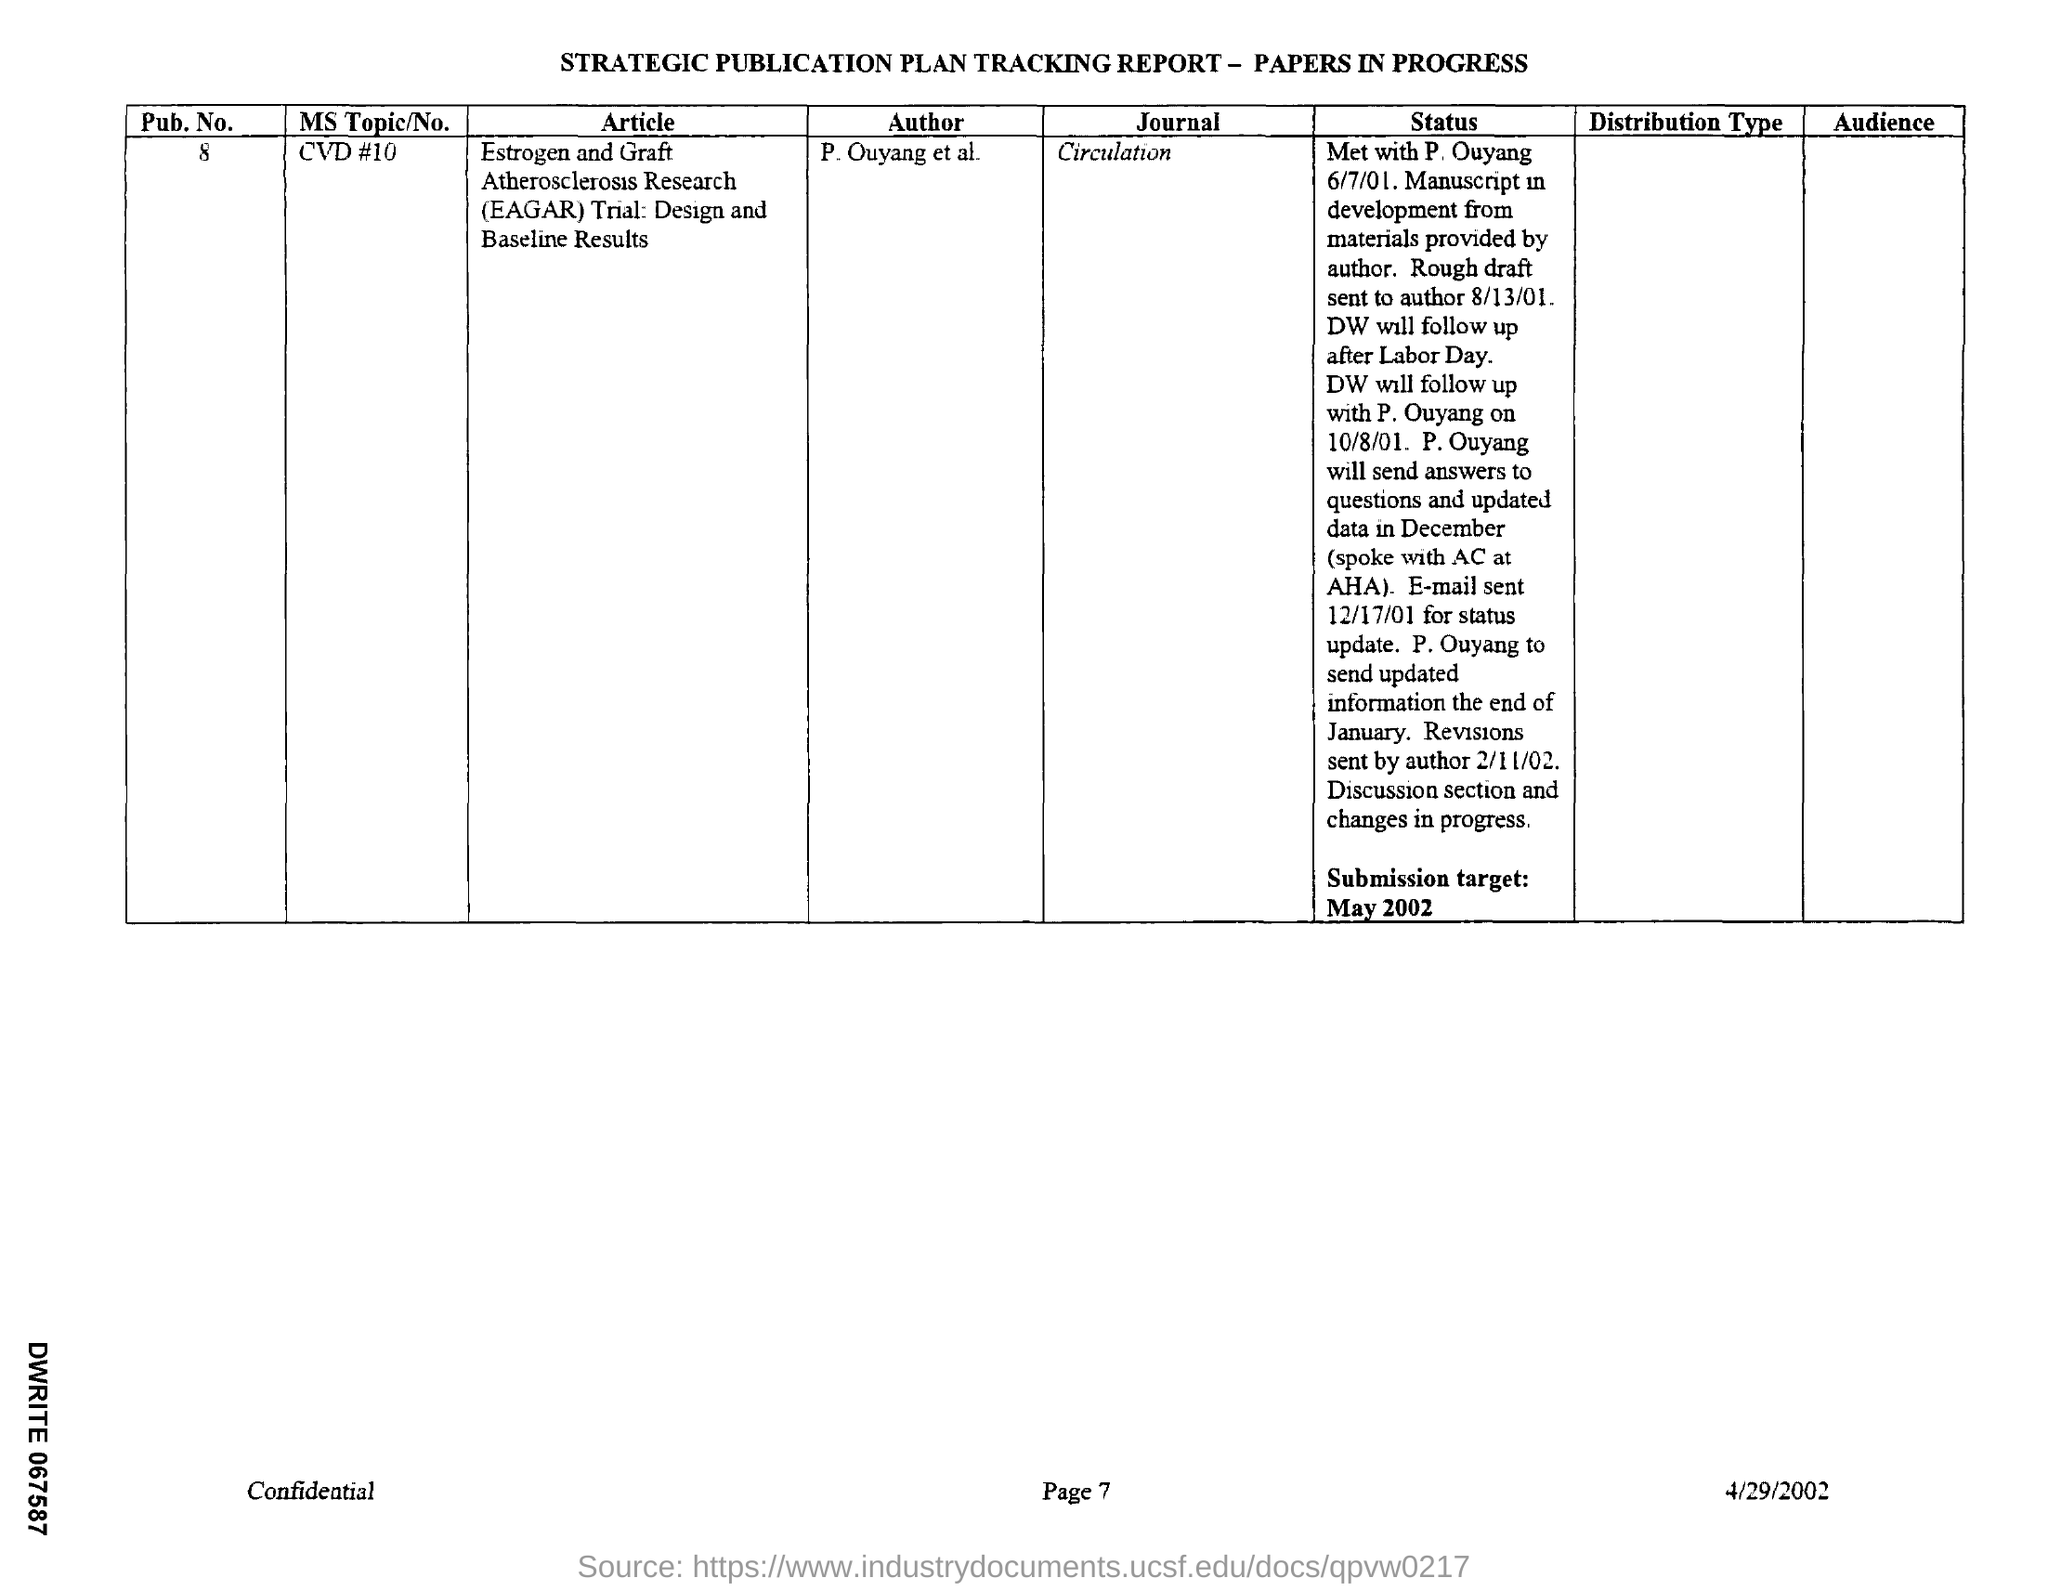What is the Pub.No.?
Make the answer very short. 8. What is the MS Topic/No.?
Ensure brevity in your answer.  CVD #10. What is the name of the Journal?
Ensure brevity in your answer.  Circulation. Who is the Author?
Provide a succinct answer. P. Ouyang et al. What is the date mentioned in the document?
Make the answer very short. 4/29/2002. 